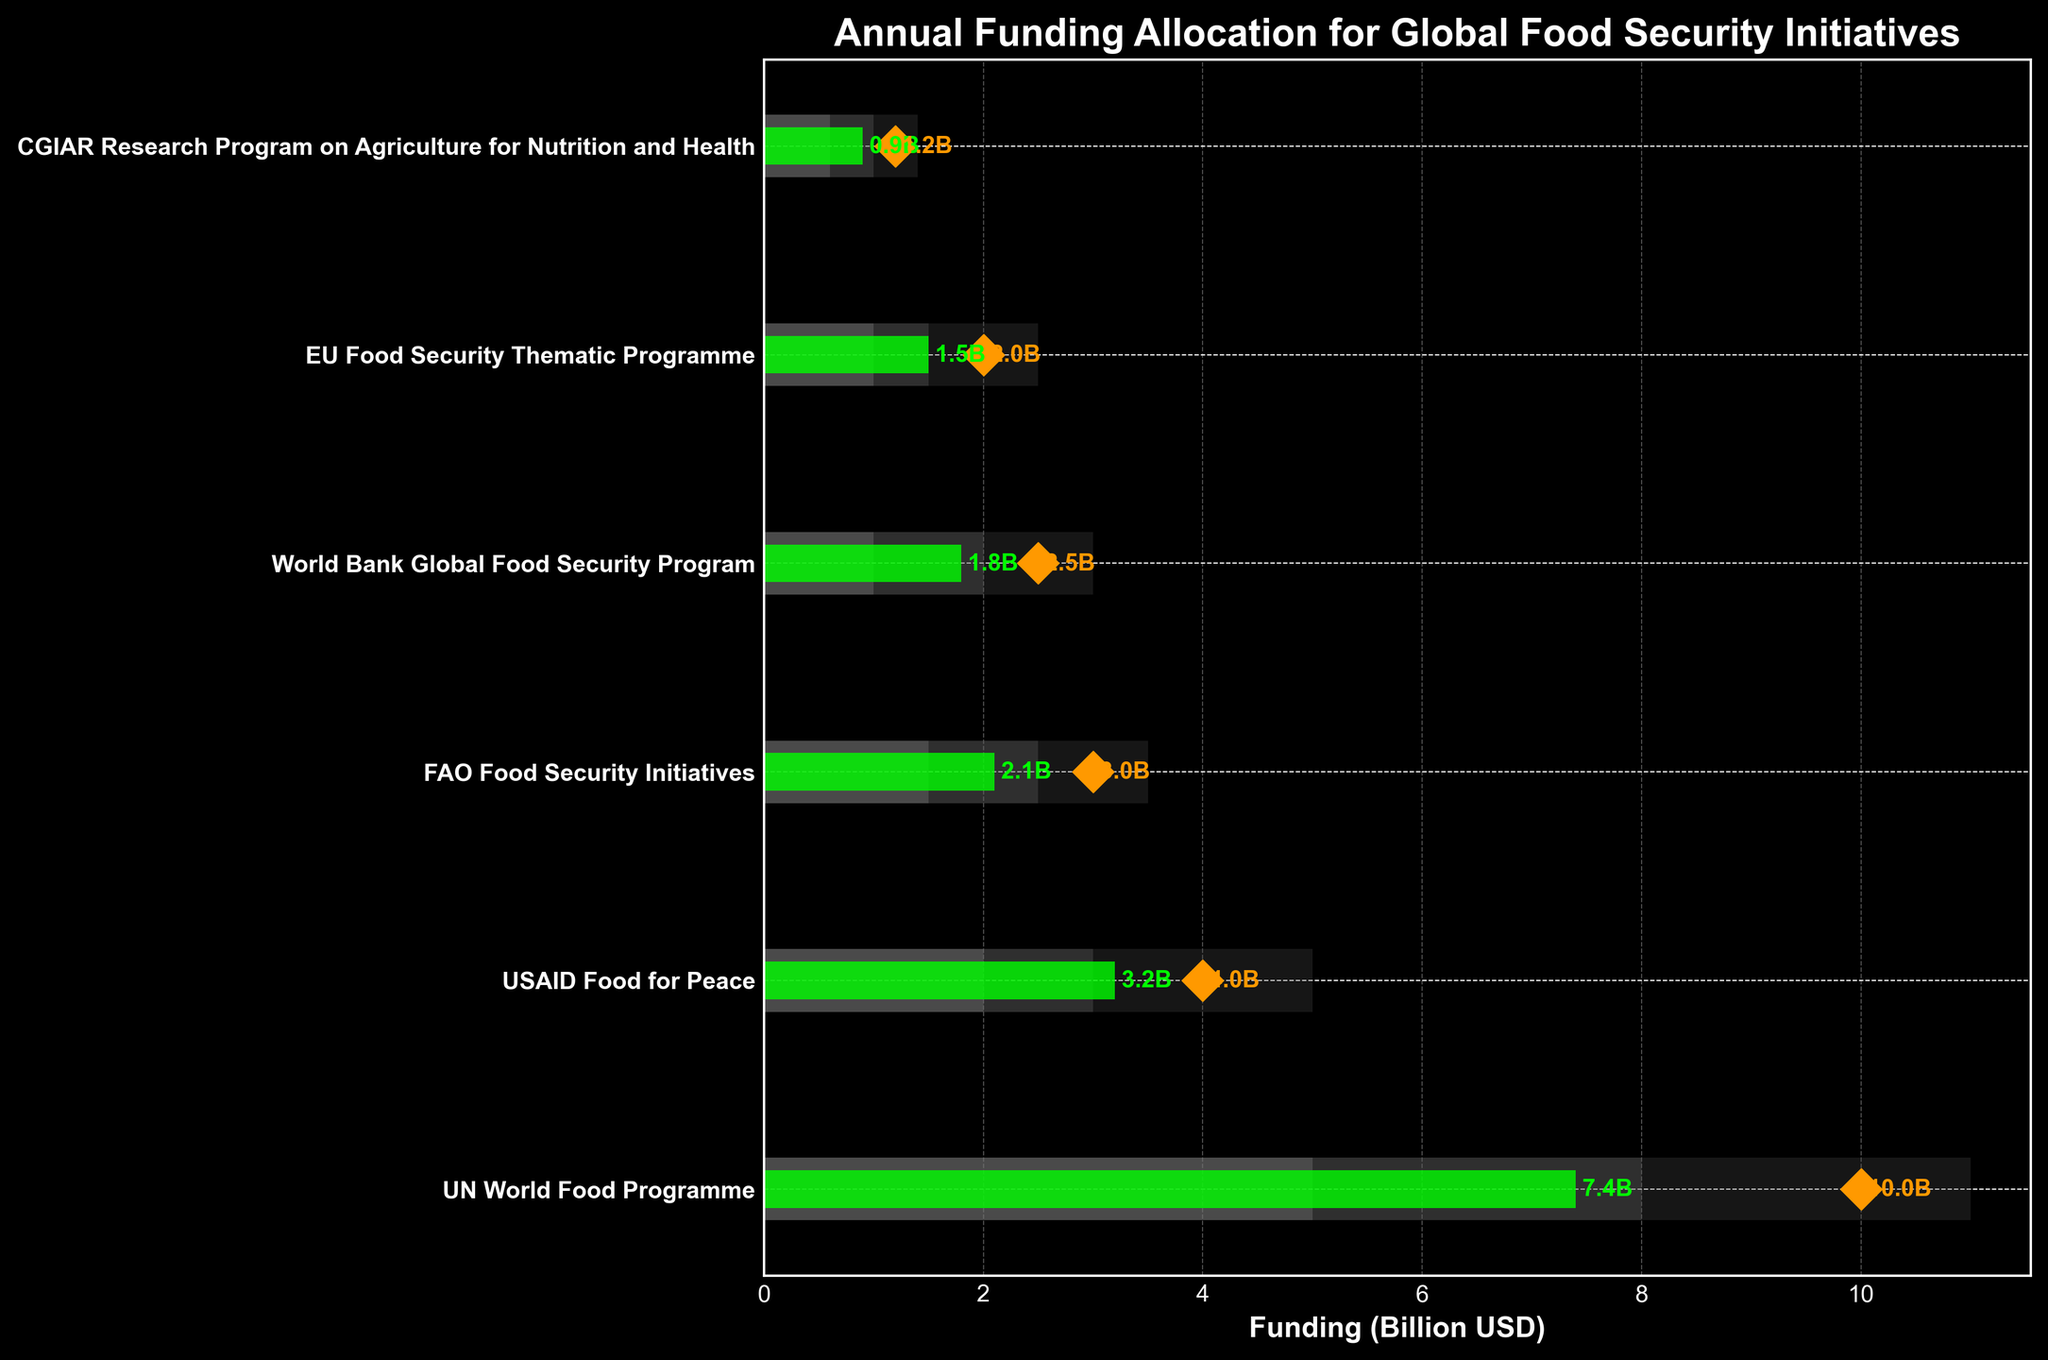What is the title of the figure? The title of the figure is located at the top and provides a summary of the visual information presented.
Answer: Annual Funding Allocation for Global Food Security Initiatives How many categories are displayed in the figure? Count the distinct categories listed on the y-axis of the chart.
Answer: Six Which category received the highest actual funding? Look at the green bars, which represent actual funding, and identify the longest bar.
Answer: UN World Food Programme What is the target funding for USAID Food for Peace? Locate the diamond marker on the horizontal scale for the "USAID Food for Peace" category.
Answer: 4 Billion USD Which categories have actual funding below their low benchmark? Compare the green bars to the gray low benchmark bars; find which green bars are shorter.
Answer: CGIAR Research Program on Agriculture for Nutrition and Health What is the difference between the actual and target funding for the FAO Food Security Initiatives? Subtract the actual funding amount from the target funding amount for FAO Food Security Initiatives category. 3B (target) - 2.1B (actual) = 0.9B
Answer: 0.9 Billion USD Which category's actual funding is closest to its target? Compare the distances between the end of each green bar and the corresponding diamond markers for all categories; identify the smallest gap.
Answer: World Bank Global Food Security Program What is the range of the medium benchmark for the EU Food Security Thematic Programme? The medium benchmark range is the value span of the middle gray bar for the EU Food Security Thematic Programme. From the start of the medium bar to its end.
Answer: 1 - 1.5 Billion USD How many categories have their actual funding surpassing the medium benchmark but below the high benchmark? Check which green bars exceed the second gray benchmark but do not reach the end of the tallest bars across all categories.
Answer: Two (UN World Food Programme, USAID Food for Peace) What is the total actual funding received by the World Bank Global Food Security Program and the EU Food Security Thematic Programme? Add the actual funding amounts for both categories: 1.8B (World Bank) + 1.5B (EU Program).
Answer: 3.3 Billion USD 